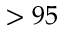<formula> <loc_0><loc_0><loc_500><loc_500>> 9 5</formula> 